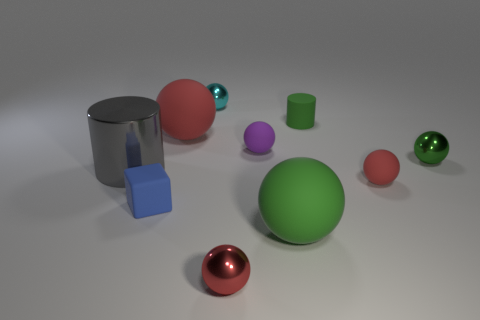Are there the same number of blue cubes behind the tiny cyan sphere and tiny cyan things that are to the right of the big metallic object? After examining the image closely, it's noticeable that there is one blue cube located behind the small cyan sphere. To the right of the large metallic cylinder, there appears to be two tiny cyan cylinders. This indicates that there aren't an equal number of blue cubes and tiny cyan objects in the specified areas. Therefore, the answer to the question is no; there is one blue cube behind the tiny cyan sphere and two tiny cyan cylinders to the right of the big metallic object. 